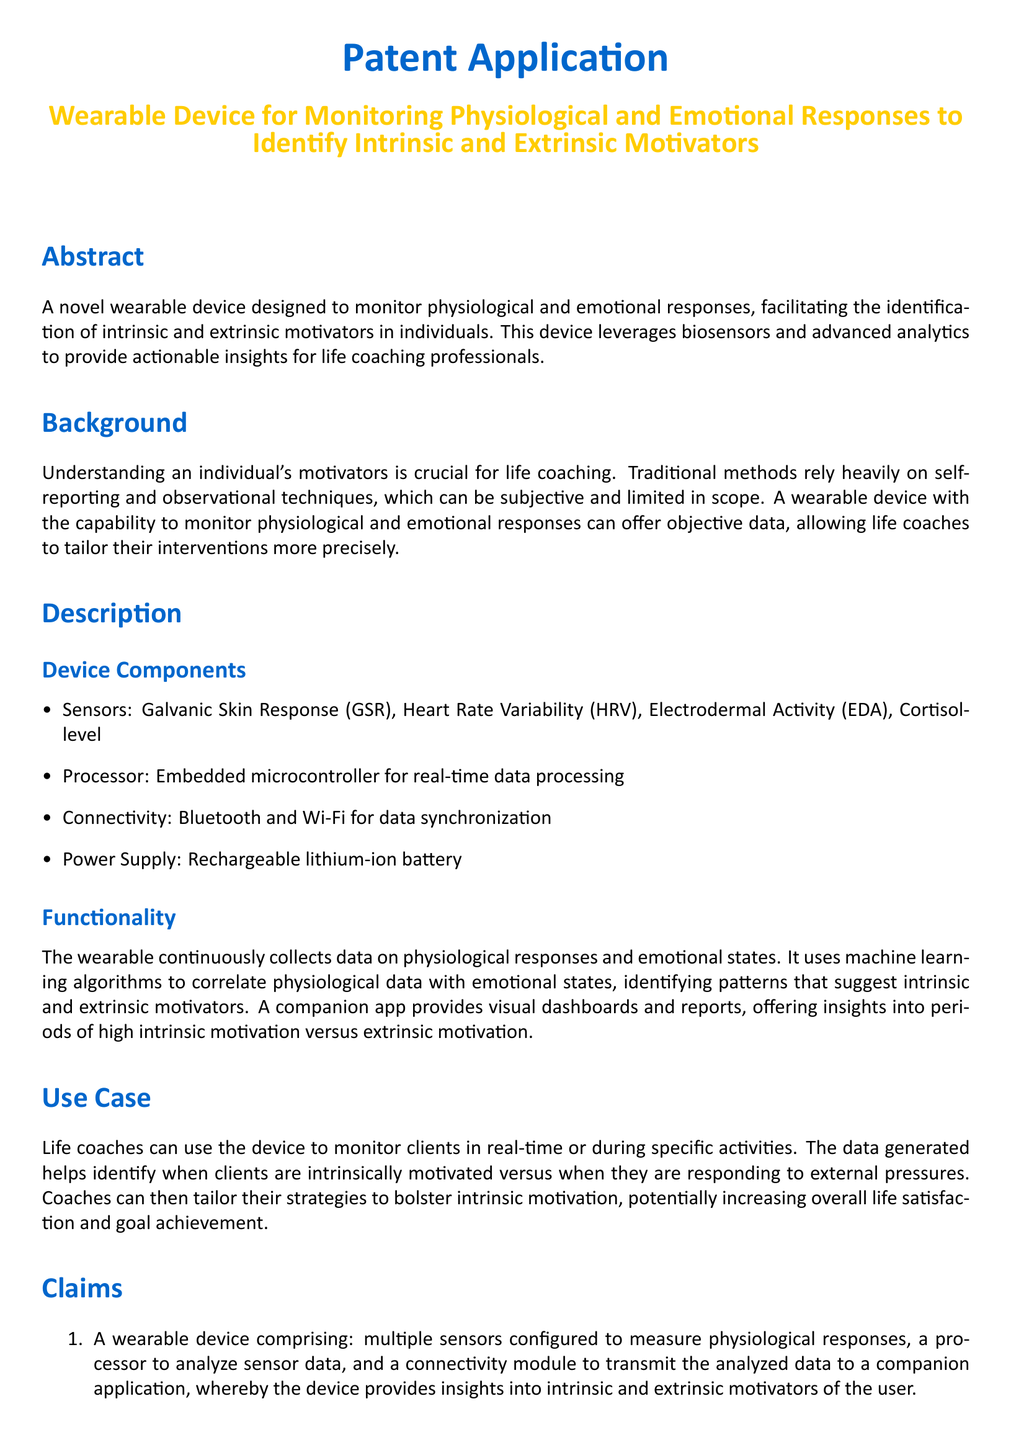What is the main purpose of the wearable device? The main purpose is to monitor physiological and emotional responses to identify intrinsic and extrinsic motivators.
Answer: To identify intrinsic and extrinsic motivators How many sensors does the device comprise? The document enumerates the types of sensors listed but does not specify a total number.
Answer: Multiple sensors What is one type of sensor mentioned in the document? The document lists specific types of sensors used in the device, including Galvanic Skin Response sensor.
Answer: Galvanic Skin Response sensor What technology does the device use to analyze data? The document mentions the use of machine learning algorithms for data analysis.
Answer: Machine learning algorithms What is the power supply type for the device? The document defines the type of power supply used in the device.
Answer: Rechargeable lithium-ion battery What does the companion app provide? The companion app offers specific functions mentioned in the document, such as visual dashboards.
Answer: Visual dashboards and reports What is the role of life coaches in relation to the wearable device? The document describes how life coaches can utilize the device for monitoring clients.
Answer: Monitor clients in real-time Under what conditions can the device be used? The document provides information on the specific contexts in which the device can be utilized effectively.
Answer: During specific activities 